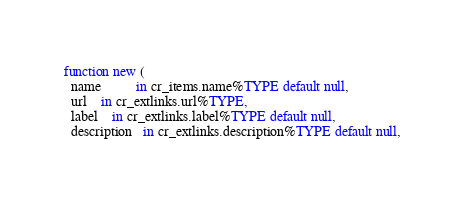<code> <loc_0><loc_0><loc_500><loc_500><_SQL_>function new (
  name          in cr_items.name%TYPE default null,
  url   	in cr_extlinks.url%TYPE,
  label   	in cr_extlinks.label%TYPE default null,
  description   in cr_extlinks.description%TYPE default null,</code> 